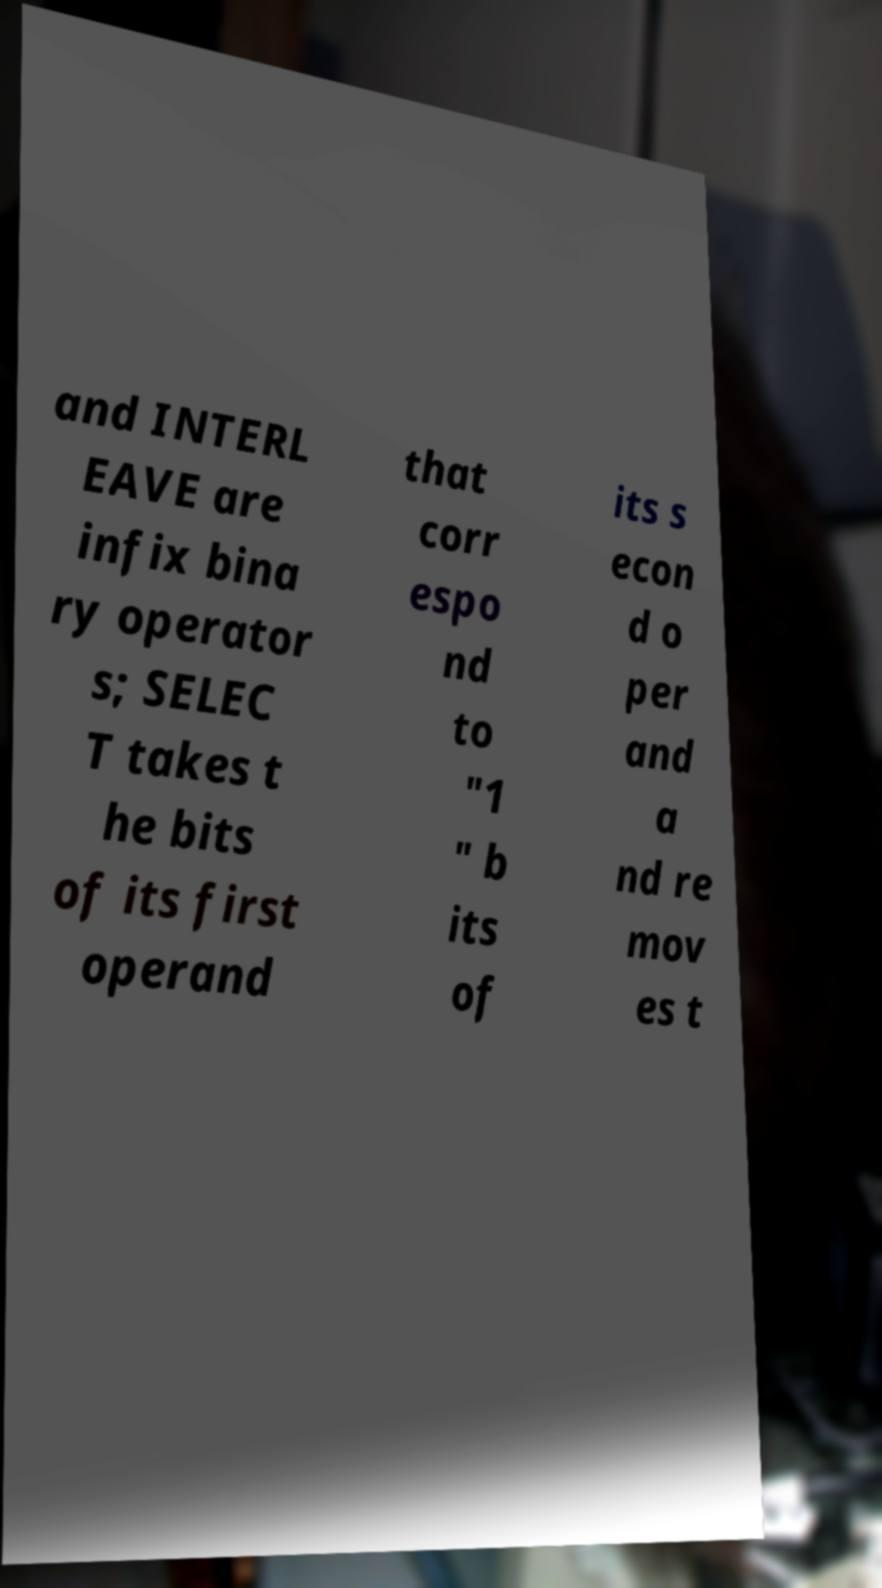There's text embedded in this image that I need extracted. Can you transcribe it verbatim? and INTERL EAVE are infix bina ry operator s; SELEC T takes t he bits of its first operand that corr espo nd to "1 " b its of its s econ d o per and a nd re mov es t 